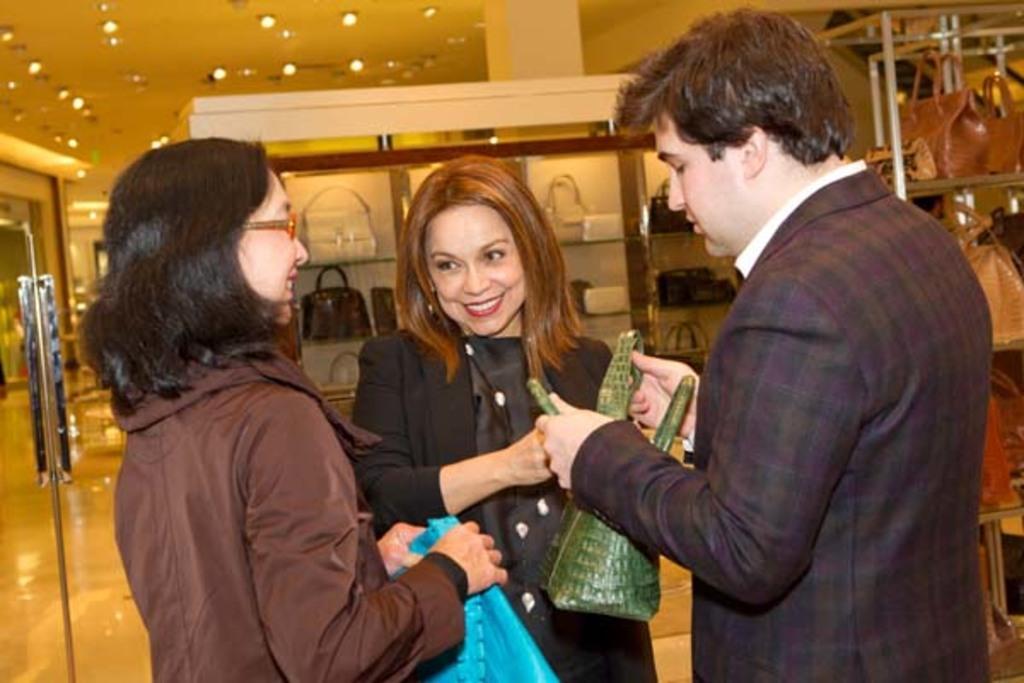Could you give a brief overview of what you see in this image? In this picture we can see a man holding a bag on the right side. We can see a woman holding a bag on the left side. There is another woman smiling. We can see a few bags on a glass cupboard. There are some bags on the racks on the right side. Some lights are visible on top. 